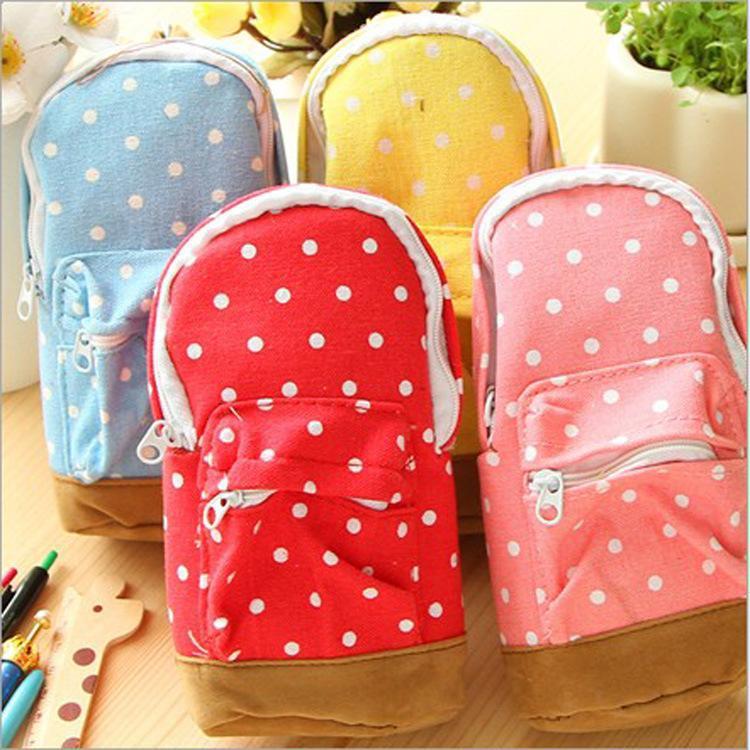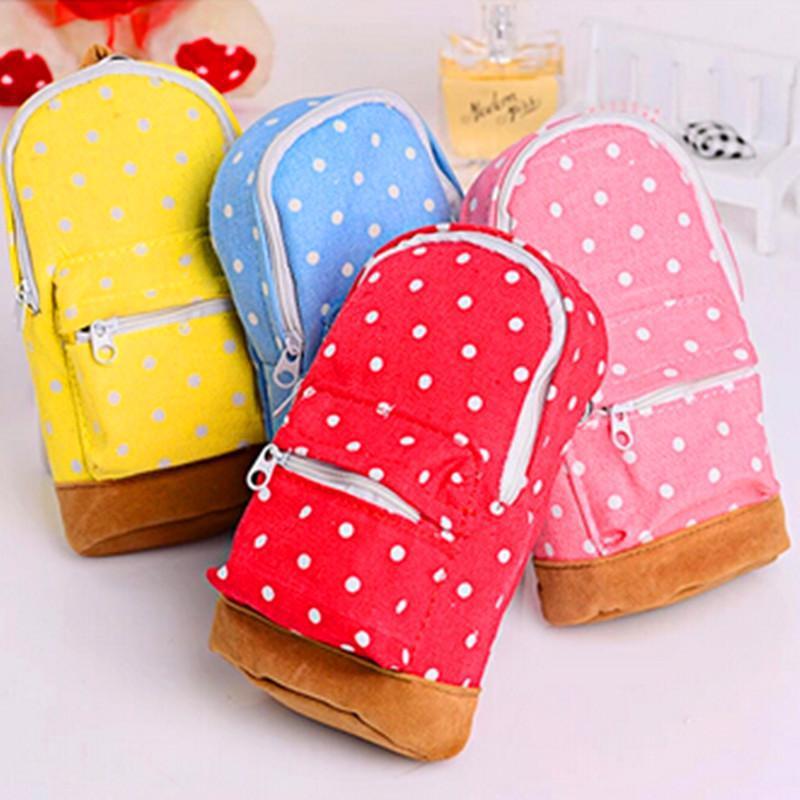The first image is the image on the left, the second image is the image on the right. For the images displayed, is the sentence "At least one image shows exactly four pencil cases of different solid colors." factually correct? Answer yes or no. No. The first image is the image on the left, the second image is the image on the right. Examine the images to the left and right. Is the description "There's exactly four small bags in the left image." accurate? Answer yes or no. Yes. 